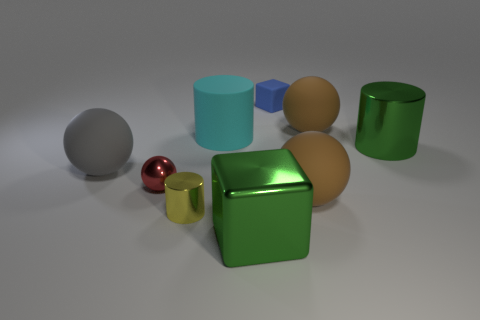Subtract all yellow shiny cylinders. How many cylinders are left? 2 Subtract all yellow cylinders. How many brown balls are left? 2 Subtract all red balls. How many balls are left? 3 Add 1 yellow rubber spheres. How many objects exist? 10 Subtract all cylinders. How many objects are left? 6 Subtract all green balls. Subtract all yellow cylinders. How many balls are left? 4 Add 3 green shiny cubes. How many green shiny cubes exist? 4 Subtract 1 red spheres. How many objects are left? 8 Subtract all small yellow objects. Subtract all cyan things. How many objects are left? 7 Add 2 small things. How many small things are left? 5 